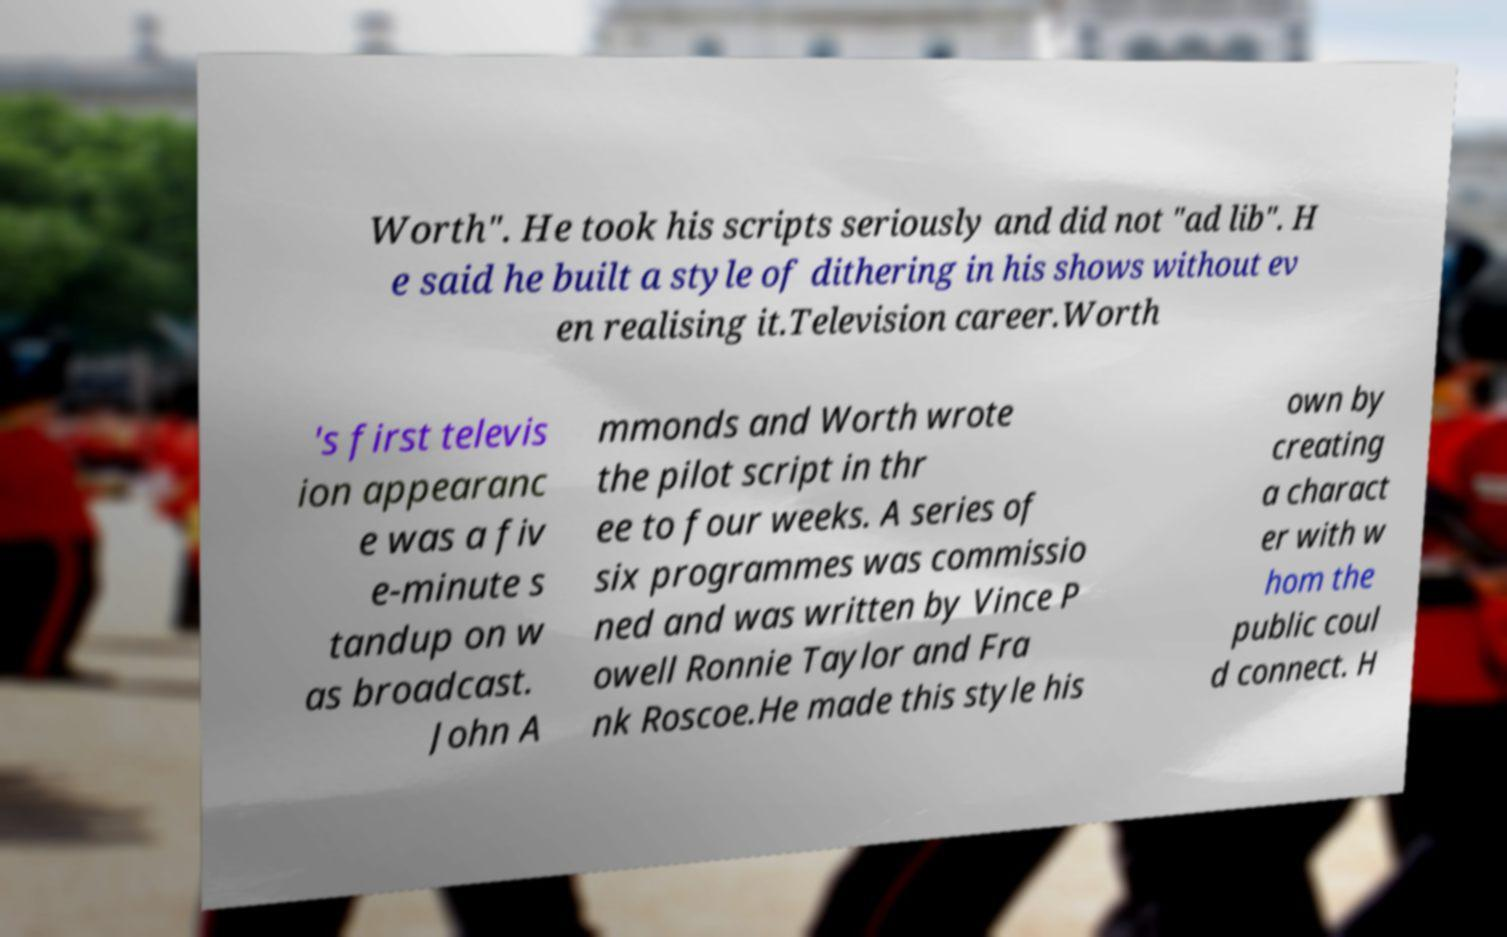I need the written content from this picture converted into text. Can you do that? Worth". He took his scripts seriously and did not "ad lib". H e said he built a style of dithering in his shows without ev en realising it.Television career.Worth 's first televis ion appearanc e was a fiv e-minute s tandup on w as broadcast. John A mmonds and Worth wrote the pilot script in thr ee to four weeks. A series of six programmes was commissio ned and was written by Vince P owell Ronnie Taylor and Fra nk Roscoe.He made this style his own by creating a charact er with w hom the public coul d connect. H 